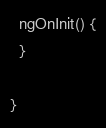Convert code to text. <code><loc_0><loc_0><loc_500><loc_500><_TypeScript_>  ngOnInit() {
  }

}
</code> 